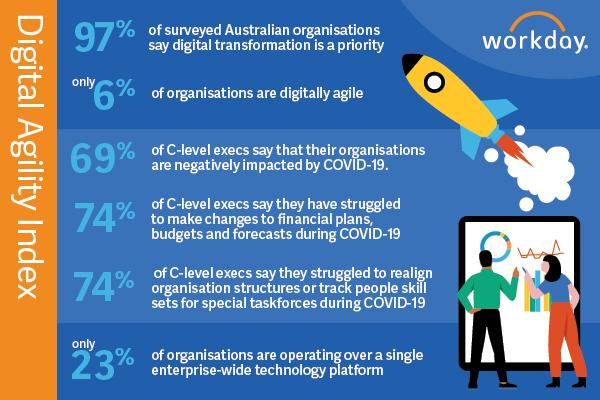Specify some key components in this picture. Only 3% of organizations do not consider digital transformation a priority. The Digital Agility Index measurement is a quantitative assessment of an organization's ability to effectively adapt to changing business conditions in the digital landscape. 